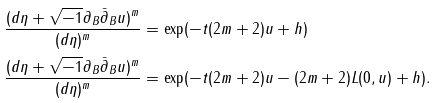Convert formula to latex. <formula><loc_0><loc_0><loc_500><loc_500>\frac { ( d \eta + \sqrt { - 1 } \partial _ { B } \bar { \partial } _ { B } u ) ^ { m } } { ( d \eta ) ^ { m } } & = \exp ( - t ( 2 m + 2 ) u + h ) \\ \frac { ( d \eta + \sqrt { - 1 } \partial _ { B } \bar { \partial } _ { B } u ) ^ { m } } { ( d \eta ) ^ { m } } & = \exp ( - t ( 2 m + 2 ) u - ( 2 m + 2 ) L ( 0 , u ) + h ) .</formula> 